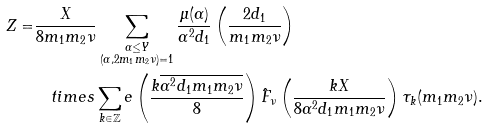<formula> <loc_0><loc_0><loc_500><loc_500>Z = & \frac { X } { 8 m _ { 1 } m _ { 2 } \nu } \sum _ { \substack { \alpha \leq Y \\ ( \alpha , 2 m _ { 1 } m _ { 2 } \nu ) = 1 } } \frac { \mu ( \alpha ) } { \alpha ^ { 2 } d _ { 1 } } \left ( \frac { 2 d _ { 1 } } { m _ { 1 } m _ { 2 } \nu } \right ) \\ & \quad t i m e s \sum _ { k \in \mathbb { Z } } e \left ( \frac { k \overline { \alpha ^ { 2 } d _ { 1 } m _ { 1 } m _ { 2 } \nu } } { 8 } \right ) \hat { F } _ { \nu } \left ( \frac { k X } { 8 \alpha ^ { 2 } d _ { 1 } m _ { 1 } m _ { 2 } \nu } \right ) \tau _ { k } ( m _ { 1 } m _ { 2 } \nu ) .</formula> 